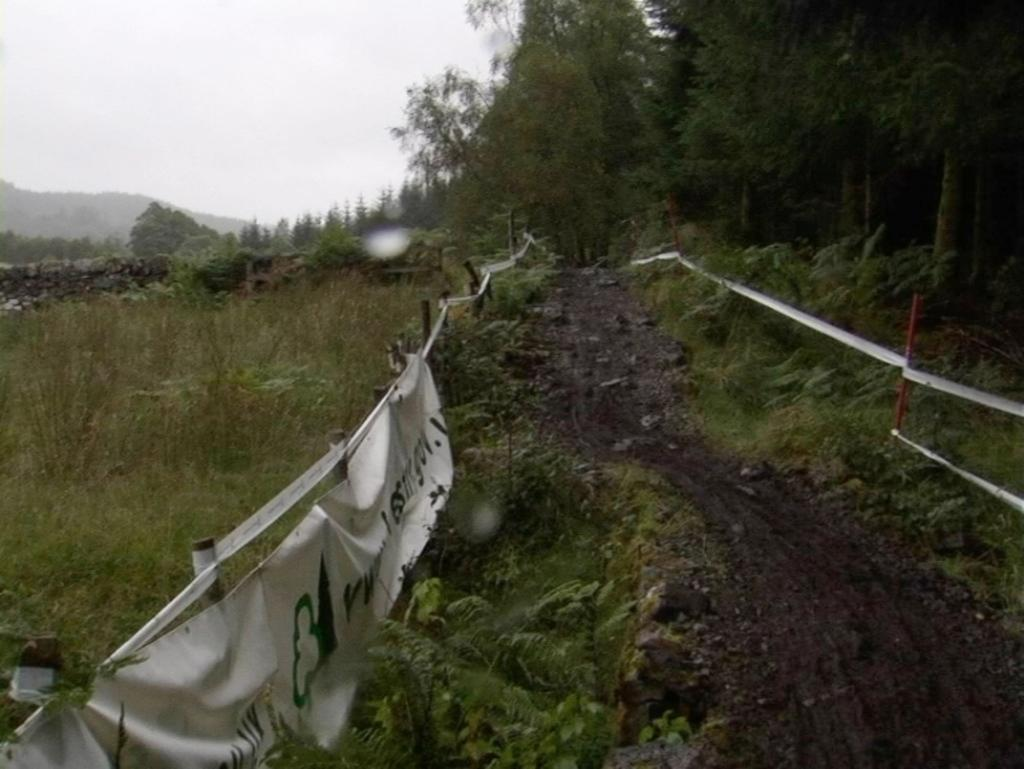What is present in the image that is used for displaying messages or information? There are banners in the image. What color are the banners? The banners are white in color. How are the banners supported or held up? The banners are attached to poles. What type of natural environment can be seen in the background of the image? There is grass and trees visible in the background of the image. What is the color of the sky in the image? The sky is white in color. Can you see any sticks in the image? There are no sticks visible in the image. 